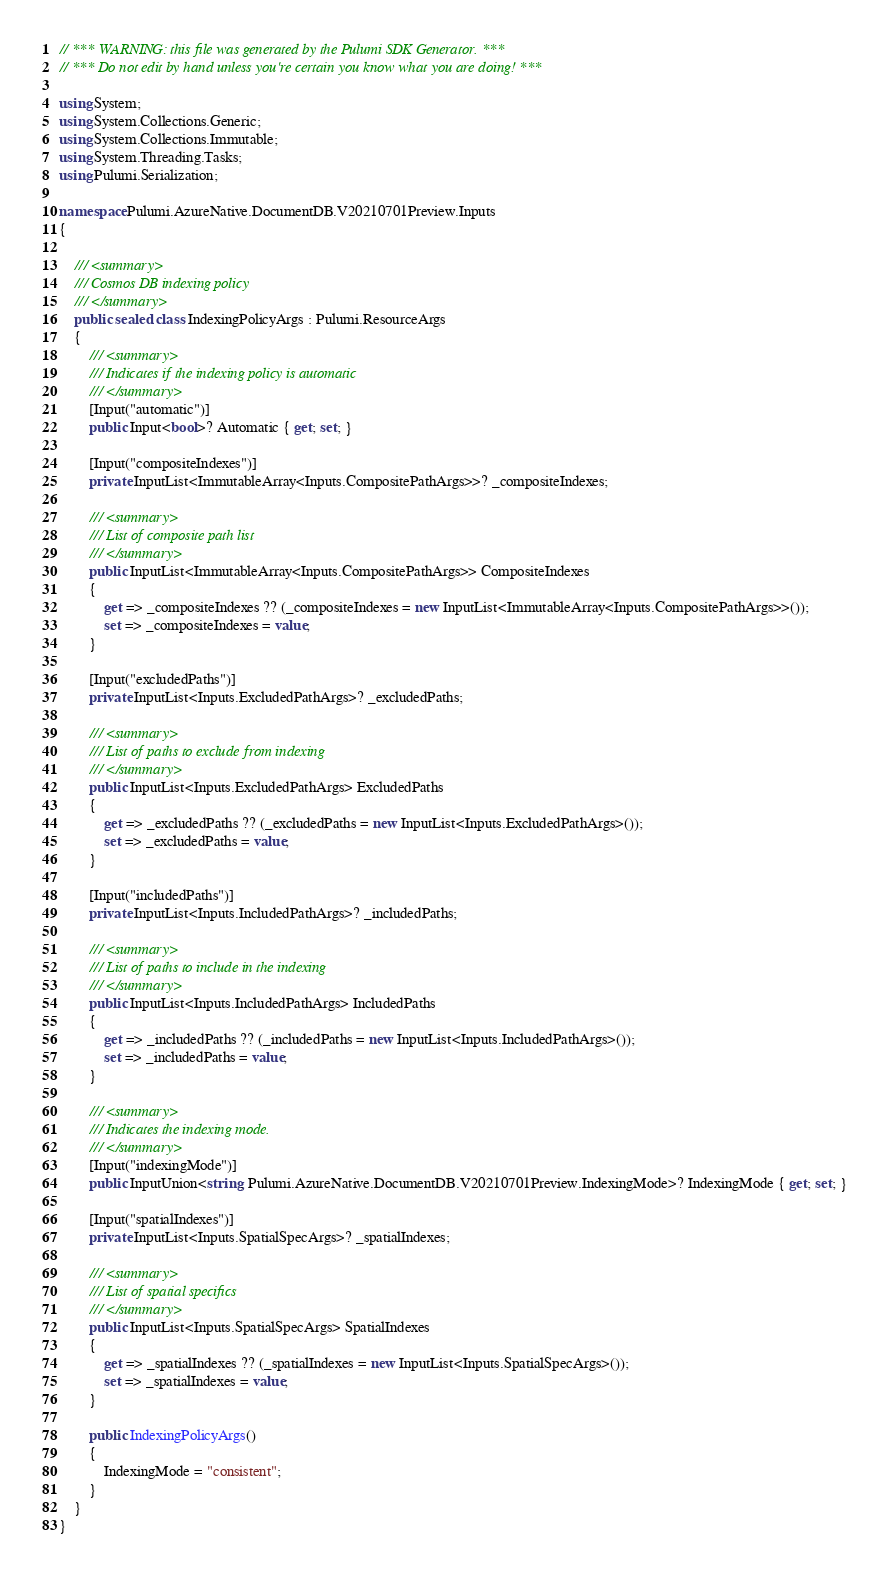Convert code to text. <code><loc_0><loc_0><loc_500><loc_500><_C#_>// *** WARNING: this file was generated by the Pulumi SDK Generator. ***
// *** Do not edit by hand unless you're certain you know what you are doing! ***

using System;
using System.Collections.Generic;
using System.Collections.Immutable;
using System.Threading.Tasks;
using Pulumi.Serialization;

namespace Pulumi.AzureNative.DocumentDB.V20210701Preview.Inputs
{

    /// <summary>
    /// Cosmos DB indexing policy
    /// </summary>
    public sealed class IndexingPolicyArgs : Pulumi.ResourceArgs
    {
        /// <summary>
        /// Indicates if the indexing policy is automatic
        /// </summary>
        [Input("automatic")]
        public Input<bool>? Automatic { get; set; }

        [Input("compositeIndexes")]
        private InputList<ImmutableArray<Inputs.CompositePathArgs>>? _compositeIndexes;

        /// <summary>
        /// List of composite path list
        /// </summary>
        public InputList<ImmutableArray<Inputs.CompositePathArgs>> CompositeIndexes
        {
            get => _compositeIndexes ?? (_compositeIndexes = new InputList<ImmutableArray<Inputs.CompositePathArgs>>());
            set => _compositeIndexes = value;
        }

        [Input("excludedPaths")]
        private InputList<Inputs.ExcludedPathArgs>? _excludedPaths;

        /// <summary>
        /// List of paths to exclude from indexing
        /// </summary>
        public InputList<Inputs.ExcludedPathArgs> ExcludedPaths
        {
            get => _excludedPaths ?? (_excludedPaths = new InputList<Inputs.ExcludedPathArgs>());
            set => _excludedPaths = value;
        }

        [Input("includedPaths")]
        private InputList<Inputs.IncludedPathArgs>? _includedPaths;

        /// <summary>
        /// List of paths to include in the indexing
        /// </summary>
        public InputList<Inputs.IncludedPathArgs> IncludedPaths
        {
            get => _includedPaths ?? (_includedPaths = new InputList<Inputs.IncludedPathArgs>());
            set => _includedPaths = value;
        }

        /// <summary>
        /// Indicates the indexing mode.
        /// </summary>
        [Input("indexingMode")]
        public InputUnion<string, Pulumi.AzureNative.DocumentDB.V20210701Preview.IndexingMode>? IndexingMode { get; set; }

        [Input("spatialIndexes")]
        private InputList<Inputs.SpatialSpecArgs>? _spatialIndexes;

        /// <summary>
        /// List of spatial specifics
        /// </summary>
        public InputList<Inputs.SpatialSpecArgs> SpatialIndexes
        {
            get => _spatialIndexes ?? (_spatialIndexes = new InputList<Inputs.SpatialSpecArgs>());
            set => _spatialIndexes = value;
        }

        public IndexingPolicyArgs()
        {
            IndexingMode = "consistent";
        }
    }
}
</code> 